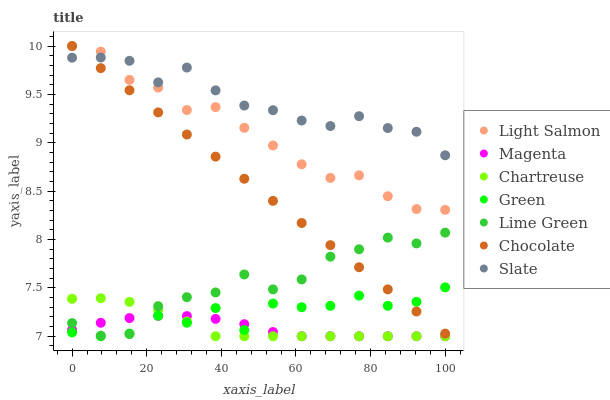Does Magenta have the minimum area under the curve?
Answer yes or no. Yes. Does Slate have the maximum area under the curve?
Answer yes or no. Yes. Does Chocolate have the minimum area under the curve?
Answer yes or no. No. Does Chocolate have the maximum area under the curve?
Answer yes or no. No. Is Chocolate the smoothest?
Answer yes or no. Yes. Is Green the roughest?
Answer yes or no. Yes. Is Slate the smoothest?
Answer yes or no. No. Is Slate the roughest?
Answer yes or no. No. Does Chartreuse have the lowest value?
Answer yes or no. Yes. Does Chocolate have the lowest value?
Answer yes or no. No. Does Chocolate have the highest value?
Answer yes or no. Yes. Does Slate have the highest value?
Answer yes or no. No. Is Chartreuse less than Slate?
Answer yes or no. Yes. Is Light Salmon greater than Chartreuse?
Answer yes or no. Yes. Does Chartreuse intersect Lime Green?
Answer yes or no. Yes. Is Chartreuse less than Lime Green?
Answer yes or no. No. Is Chartreuse greater than Lime Green?
Answer yes or no. No. Does Chartreuse intersect Slate?
Answer yes or no. No. 